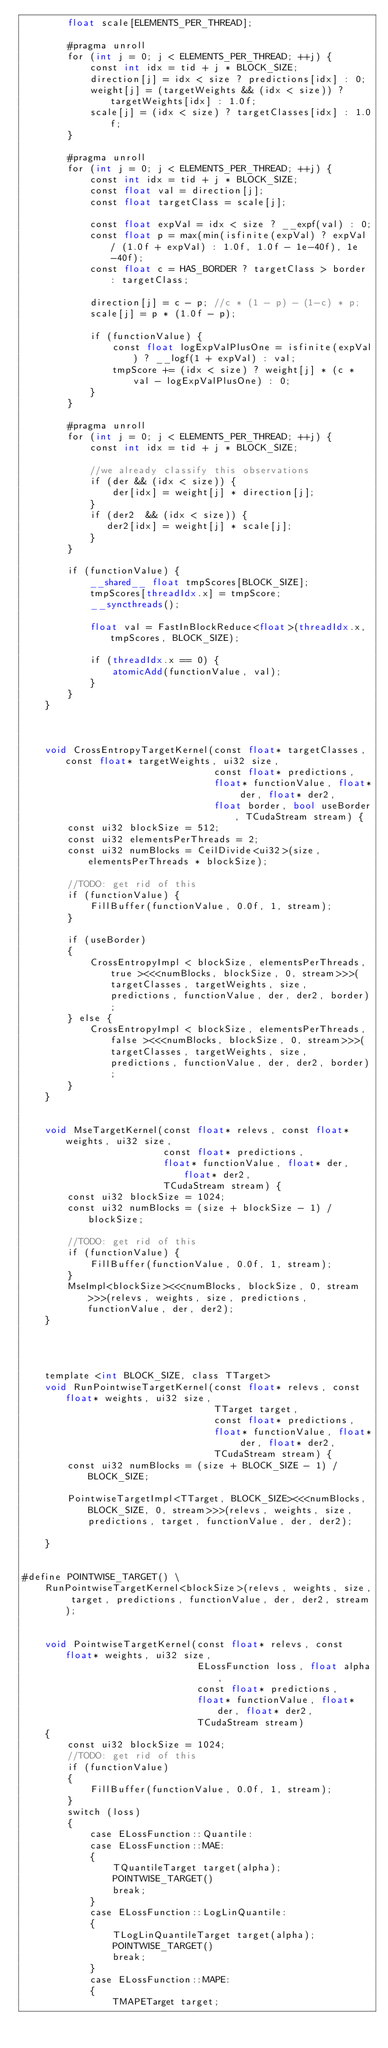<code> <loc_0><loc_0><loc_500><loc_500><_Cuda_>        float scale[ELEMENTS_PER_THREAD];

        #pragma unroll
        for (int j = 0; j < ELEMENTS_PER_THREAD; ++j) {
            const int idx = tid + j * BLOCK_SIZE;
            direction[j] = idx < size ? predictions[idx] : 0;
            weight[j] = (targetWeights && (idx < size)) ? targetWeights[idx] : 1.0f;
            scale[j] = (idx < size) ? targetClasses[idx] : 1.0f;
        }

        #pragma unroll
        for (int j = 0; j < ELEMENTS_PER_THREAD; ++j) {
            const int idx = tid + j * BLOCK_SIZE;
            const float val = direction[j];
            const float targetClass = scale[j];

            const float expVal = idx < size ? __expf(val) : 0;
            const float p = max(min(isfinite(expVal) ? expVal / (1.0f + expVal) : 1.0f, 1.0f - 1e-40f), 1e-40f);
            const float c = HAS_BORDER ? targetClass > border : targetClass;

            direction[j] = c - p; //c * (1 - p) - (1-c) * p;
            scale[j] = p * (1.0f - p);

            if (functionValue) {
                const float logExpValPlusOne = isfinite(expVal) ? __logf(1 + expVal) : val;
                tmpScore += (idx < size) ? weight[j] * (c * val - logExpValPlusOne) : 0;
            }
        }

        #pragma unroll
        for (int j = 0; j < ELEMENTS_PER_THREAD; ++j) {
            const int idx = tid + j * BLOCK_SIZE;

            //we already classify this observations
            if (der && (idx < size)) {
                der[idx] = weight[j] * direction[j];
            }
            if (der2  && (idx < size)) {
               der2[idx] = weight[j] * scale[j];
            }
        }

        if (functionValue) {
            __shared__ float tmpScores[BLOCK_SIZE];
            tmpScores[threadIdx.x] = tmpScore;
            __syncthreads();

            float val = FastInBlockReduce<float>(threadIdx.x, tmpScores, BLOCK_SIZE);

            if (threadIdx.x == 0) {
                atomicAdd(functionValue, val);
            }
        }
    }



    void CrossEntropyTargetKernel(const float* targetClasses, const float* targetWeights, ui32 size,
                                  const float* predictions,
                                  float* functionValue, float* der, float* der2,
                                  float border, bool useBorder, TCudaStream stream) {
        const ui32 blockSize = 512;
        const ui32 elementsPerThreads = 2;
        const ui32 numBlocks = CeilDivide<ui32>(size, elementsPerThreads * blockSize);

        //TODO: get rid of this
        if (functionValue) {
            FillBuffer(functionValue, 0.0f, 1, stream);
        }

        if (useBorder)
        {
            CrossEntropyImpl < blockSize, elementsPerThreads, true ><<<numBlocks, blockSize, 0, stream>>>(targetClasses, targetWeights, size, predictions, functionValue, der, der2, border);
        } else {
            CrossEntropyImpl < blockSize, elementsPerThreads, false ><<<numBlocks, blockSize, 0, stream>>>(targetClasses, targetWeights, size, predictions, functionValue, der, der2, border);
        }
    }


    void MseTargetKernel(const float* relevs, const float* weights, ui32 size,
                         const float* predictions,
                         float* functionValue, float* der, float* der2,
                         TCudaStream stream) {
        const ui32 blockSize = 1024;
        const ui32 numBlocks = (size + blockSize - 1) / blockSize;

        //TODO: get rid of this
        if (functionValue) {
            FillBuffer(functionValue, 0.0f, 1, stream);
        }
        MseImpl<blockSize><<<numBlocks, blockSize, 0, stream>>>(relevs, weights, size, predictions, functionValue, der, der2);
    }




    template <int BLOCK_SIZE, class TTarget>
    void RunPointwiseTargetKernel(const float* relevs, const float* weights, ui32 size,
                                  TTarget target,
                                  const float* predictions,
                                  float* functionValue, float* der, float* der2,
                                  TCudaStream stream) {
        const ui32 numBlocks = (size + BLOCK_SIZE - 1) / BLOCK_SIZE;

        PointwiseTargetImpl<TTarget, BLOCK_SIZE><<<numBlocks, BLOCK_SIZE, 0, stream>>>(relevs, weights, size, predictions, target, functionValue, der, der2);

    }


#define POINTWISE_TARGET() \
    RunPointwiseTargetKernel<blockSize>(relevs, weights, size, target, predictions, functionValue, der, der2, stream);


    void PointwiseTargetKernel(const float* relevs, const float* weights, ui32 size,
                               ELossFunction loss, float alpha,
                               const float* predictions,
                               float* functionValue, float* der, float* der2,
                               TCudaStream stream)
    {
        const ui32 blockSize = 1024;
        //TODO: get rid of this
        if (functionValue)
        {
            FillBuffer(functionValue, 0.0f, 1, stream);
        }
        switch (loss)
        {
            case ELossFunction::Quantile:
            case ELossFunction::MAE:
            {
                TQuantileTarget target(alpha);
                POINTWISE_TARGET()
                break;
            }
            case ELossFunction::LogLinQuantile:
            {
                TLogLinQuantileTarget target(alpha);
                POINTWISE_TARGET()
                break;
            }
            case ELossFunction::MAPE:
            {
                TMAPETarget target;</code> 